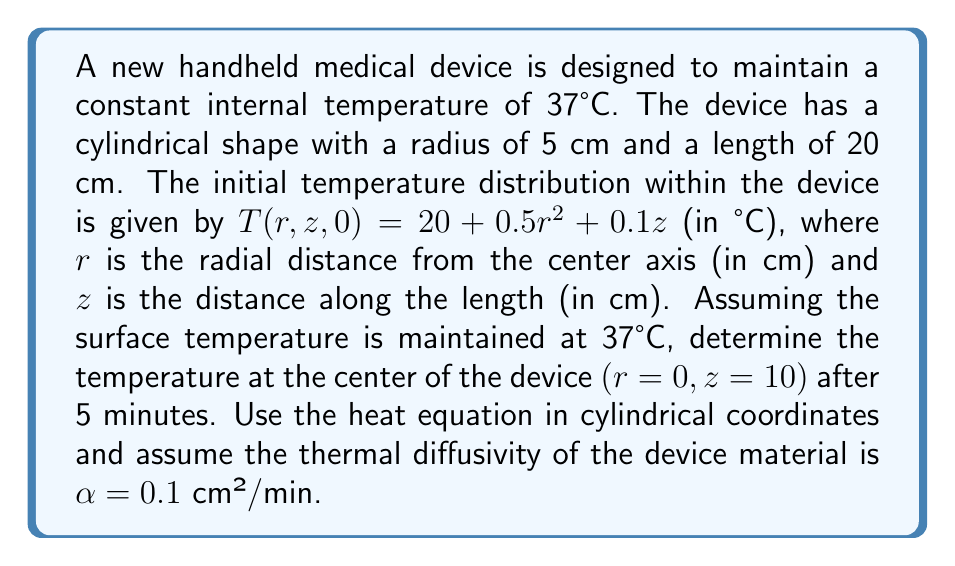Provide a solution to this math problem. To solve this problem, we'll use the heat equation in cylindrical coordinates and apply separation of variables. The steps are as follows:

1) The heat equation in cylindrical coordinates is:

   $$\frac{\partial T}{\partial t} = \alpha \left(\frac{1}{r}\frac{\partial}{\partial r}\left(r\frac{\partial T}{\partial r}\right) + \frac{\partial^2 T}{\partial z^2}\right)$$

2) The boundary conditions are:
   $T(5,z,t) = 37$ (surface temperature)
   $T(r,0,t) = T(r,20,t) = 37$ (ends of cylinder)
   $T(r,z,0) = 20 + 0.5r^2 + 0.1z$ (initial condition)

3) We can separate the solution into steady-state and transient parts:
   $T(r,z,t) = T_{ss}(r,z) + T_{tr}(r,z,t)$

4) The steady-state solution is simply $T_{ss}(r,z) = 37$, as this satisfies the boundary conditions.

5) For the transient part, we use separation of variables:
   $T_{tr}(r,z,t) = R(r)Z(z)e^{-\lambda^2\alpha t}$

6) Solving the resulting Bessel equation and applying boundary conditions, we get:

   $$T_{tr}(r,z,t) = \sum_{m=1}^{\infty}\sum_{n=1}^{\infty} A_{mn}J_0(\beta_m r)\sin(\frac{n\pi z}{20})e^{-(\beta_m^2 + (\frac{n\pi}{20})^2)\alpha t}$$

   where $J_0$ is the Bessel function of the first kind of order 0, and $\beta_m$ are its zeros.

7) The coefficients $A_{mn}$ are found using the initial condition:

   $$A_{mn} = \frac{4}{20J_1^2(\beta_m5)}\int_0^5\int_0^{20} r(20 + 0.5r^2 + 0.1z - 37)J_0(\beta_m r)\sin(\frac{n\pi z}{20})drdz$$

8) Computing these integrals and summing the series is complex. In practice, we would use numerical methods or software to evaluate this.

9) For the center of the device $(r=0, z=10)$ after 5 minutes, we have:

   $$T(0,10,5) = 37 + \sum_{m=1}^{\infty}\sum_{n=1}^{\infty} A_{mn}J_0(0)\sin(\frac{n\pi}{2})e^{-(\beta_m^2 + (\frac{n\pi}{20})^2)0.5}$$

10) Note that $J_0(0) = 1$ and $\sin(\frac{n\pi}{2})$ is non-zero only for odd $n$.

11) The exact solution would require computing many terms of this series. However, due to the exponential decay, after 5 minutes, the temperature will be very close to the steady-state value of 37°C.
Answer: $37°C$ (approximately) 